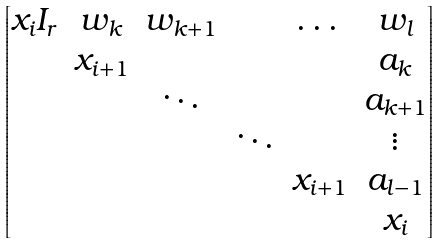Convert formula to latex. <formula><loc_0><loc_0><loc_500><loc_500>\begin{bmatrix} x _ { i } I _ { r } & w _ { k } & w _ { k + 1 } & & \dots & w _ { l } \\ & x _ { i + 1 } & & & & a _ { k } \\ & & \ddots & & & a _ { k + 1 } \\ & & & \ddots & & \vdots \\ & & & & x _ { i + 1 } & a _ { l - 1 } \\ & & & & & x _ { i } \\ \end{bmatrix}</formula> 